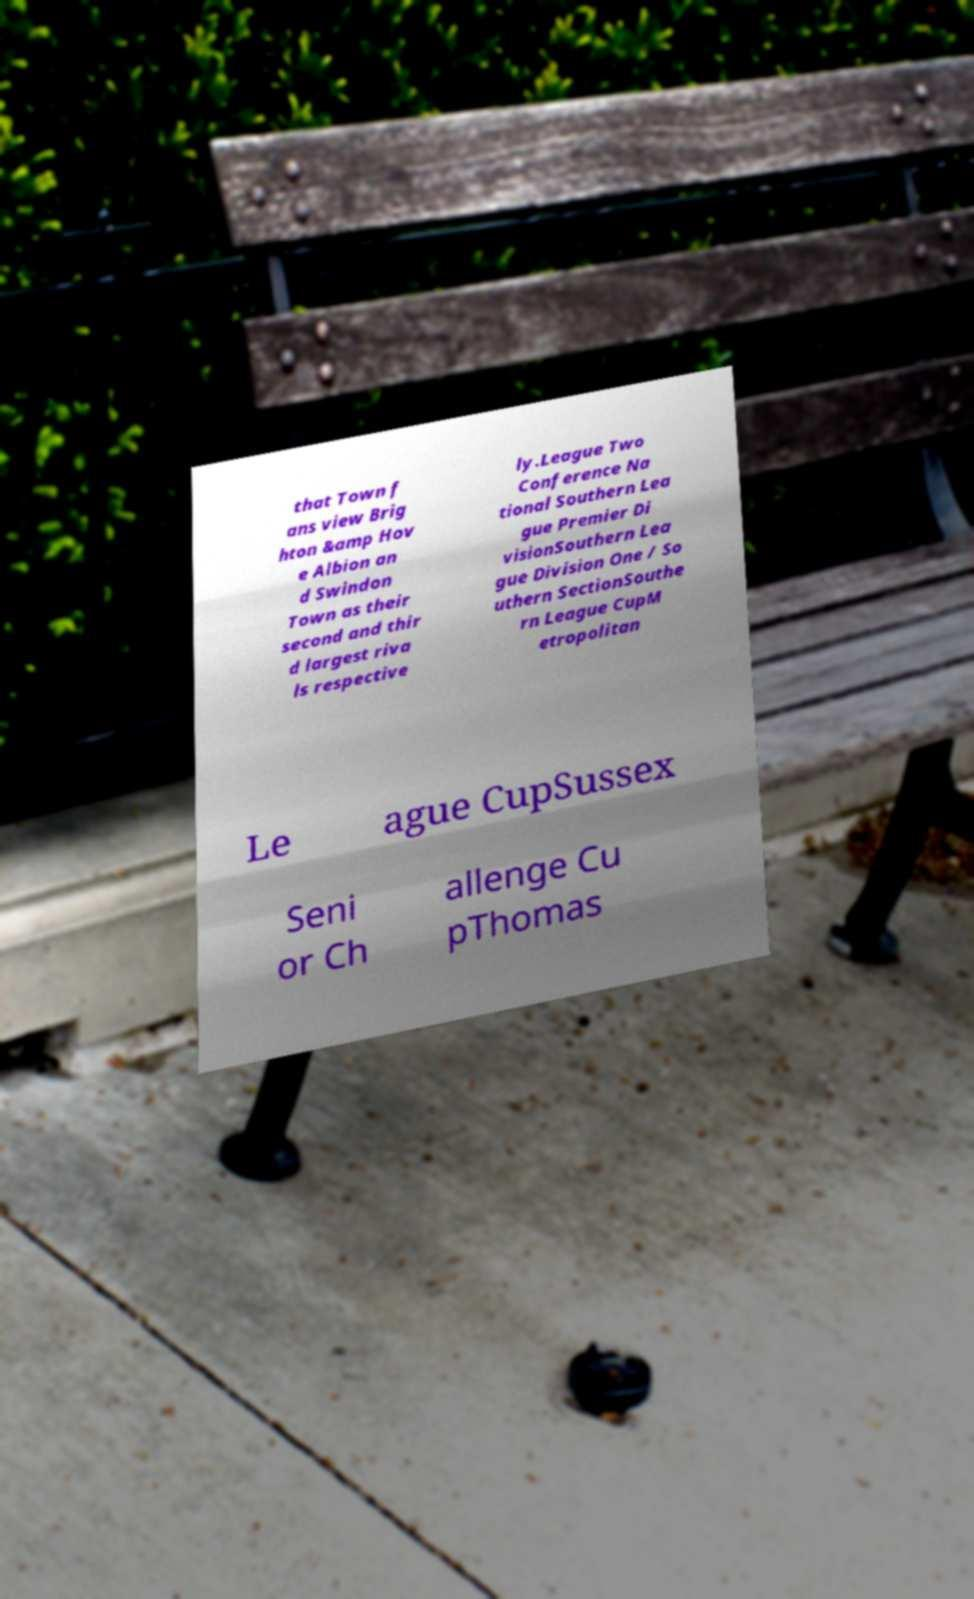Can you accurately transcribe the text from the provided image for me? that Town f ans view Brig hton &amp Hov e Albion an d Swindon Town as their second and thir d largest riva ls respective ly.League Two Conference Na tional Southern Lea gue Premier Di visionSouthern Lea gue Division One / So uthern SectionSouthe rn League CupM etropolitan Le ague CupSussex Seni or Ch allenge Cu pThomas 